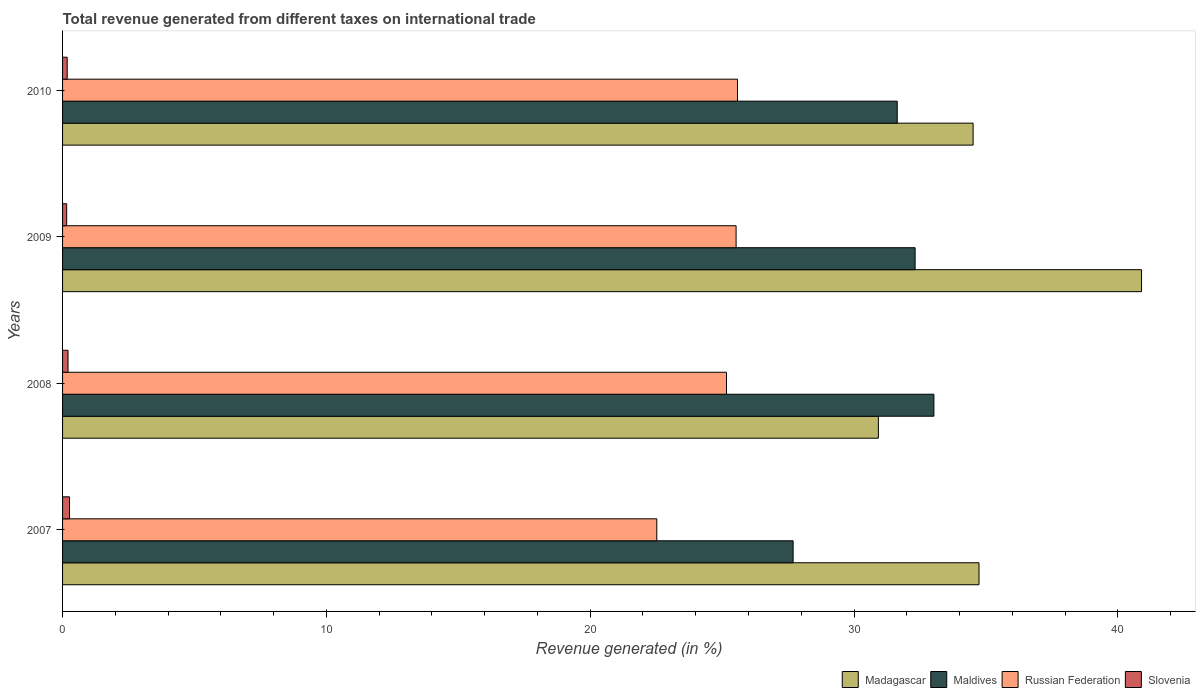Are the number of bars per tick equal to the number of legend labels?
Your answer should be compact. Yes. Are the number of bars on each tick of the Y-axis equal?
Your response must be concise. Yes. How many bars are there on the 3rd tick from the bottom?
Your answer should be very brief. 4. What is the label of the 1st group of bars from the top?
Provide a succinct answer. 2010. In how many cases, is the number of bars for a given year not equal to the number of legend labels?
Offer a very short reply. 0. What is the total revenue generated in Maldives in 2010?
Provide a short and direct response. 31.64. Across all years, what is the maximum total revenue generated in Madagascar?
Keep it short and to the point. 40.9. Across all years, what is the minimum total revenue generated in Russian Federation?
Make the answer very short. 22.52. In which year was the total revenue generated in Slovenia minimum?
Your answer should be very brief. 2009. What is the total total revenue generated in Maldives in the graph?
Offer a very short reply. 124.68. What is the difference between the total revenue generated in Russian Federation in 2007 and that in 2009?
Your response must be concise. -3.01. What is the difference between the total revenue generated in Madagascar in 2010 and the total revenue generated in Maldives in 2008?
Provide a short and direct response. 1.49. What is the average total revenue generated in Russian Federation per year?
Your answer should be very brief. 24.7. In the year 2007, what is the difference between the total revenue generated in Madagascar and total revenue generated in Slovenia?
Provide a short and direct response. 34.47. In how many years, is the total revenue generated in Madagascar greater than 28 %?
Your response must be concise. 4. What is the ratio of the total revenue generated in Russian Federation in 2008 to that in 2010?
Keep it short and to the point. 0.98. Is the total revenue generated in Slovenia in 2007 less than that in 2009?
Ensure brevity in your answer.  No. Is the difference between the total revenue generated in Madagascar in 2009 and 2010 greater than the difference between the total revenue generated in Slovenia in 2009 and 2010?
Offer a very short reply. Yes. What is the difference between the highest and the second highest total revenue generated in Maldives?
Keep it short and to the point. 0.71. What is the difference between the highest and the lowest total revenue generated in Madagascar?
Offer a terse response. 9.98. In how many years, is the total revenue generated in Madagascar greater than the average total revenue generated in Madagascar taken over all years?
Your answer should be compact. 1. Is the sum of the total revenue generated in Madagascar in 2007 and 2009 greater than the maximum total revenue generated in Slovenia across all years?
Offer a terse response. Yes. What does the 4th bar from the top in 2009 represents?
Offer a very short reply. Madagascar. What does the 4th bar from the bottom in 2008 represents?
Your response must be concise. Slovenia. Is it the case that in every year, the sum of the total revenue generated in Slovenia and total revenue generated in Russian Federation is greater than the total revenue generated in Madagascar?
Your answer should be compact. No. How many bars are there?
Provide a succinct answer. 16. Are all the bars in the graph horizontal?
Keep it short and to the point. Yes. How many years are there in the graph?
Ensure brevity in your answer.  4. Are the values on the major ticks of X-axis written in scientific E-notation?
Your response must be concise. No. Does the graph contain any zero values?
Your answer should be compact. No. Does the graph contain grids?
Give a very brief answer. No. Where does the legend appear in the graph?
Keep it short and to the point. Bottom right. How many legend labels are there?
Provide a short and direct response. 4. What is the title of the graph?
Ensure brevity in your answer.  Total revenue generated from different taxes on international trade. What is the label or title of the X-axis?
Your answer should be very brief. Revenue generated (in %). What is the Revenue generated (in %) of Madagascar in 2007?
Offer a terse response. 34.74. What is the Revenue generated (in %) in Maldives in 2007?
Provide a short and direct response. 27.69. What is the Revenue generated (in %) of Russian Federation in 2007?
Offer a terse response. 22.52. What is the Revenue generated (in %) in Slovenia in 2007?
Give a very brief answer. 0.26. What is the Revenue generated (in %) in Madagascar in 2008?
Your answer should be compact. 30.92. What is the Revenue generated (in %) in Maldives in 2008?
Keep it short and to the point. 33.03. What is the Revenue generated (in %) in Russian Federation in 2008?
Offer a terse response. 25.17. What is the Revenue generated (in %) of Slovenia in 2008?
Your answer should be very brief. 0.21. What is the Revenue generated (in %) in Madagascar in 2009?
Keep it short and to the point. 40.9. What is the Revenue generated (in %) of Maldives in 2009?
Ensure brevity in your answer.  32.32. What is the Revenue generated (in %) in Russian Federation in 2009?
Give a very brief answer. 25.53. What is the Revenue generated (in %) of Slovenia in 2009?
Your answer should be very brief. 0.16. What is the Revenue generated (in %) in Madagascar in 2010?
Make the answer very short. 34.52. What is the Revenue generated (in %) of Maldives in 2010?
Your answer should be very brief. 31.64. What is the Revenue generated (in %) in Russian Federation in 2010?
Make the answer very short. 25.58. What is the Revenue generated (in %) of Slovenia in 2010?
Give a very brief answer. 0.18. Across all years, what is the maximum Revenue generated (in %) of Madagascar?
Offer a terse response. 40.9. Across all years, what is the maximum Revenue generated (in %) in Maldives?
Ensure brevity in your answer.  33.03. Across all years, what is the maximum Revenue generated (in %) of Russian Federation?
Offer a very short reply. 25.58. Across all years, what is the maximum Revenue generated (in %) in Slovenia?
Your answer should be compact. 0.26. Across all years, what is the minimum Revenue generated (in %) in Madagascar?
Keep it short and to the point. 30.92. Across all years, what is the minimum Revenue generated (in %) of Maldives?
Your response must be concise. 27.69. Across all years, what is the minimum Revenue generated (in %) of Russian Federation?
Give a very brief answer. 22.52. Across all years, what is the minimum Revenue generated (in %) in Slovenia?
Provide a succinct answer. 0.16. What is the total Revenue generated (in %) of Madagascar in the graph?
Your answer should be compact. 141.08. What is the total Revenue generated (in %) of Maldives in the graph?
Make the answer very short. 124.68. What is the total Revenue generated (in %) in Russian Federation in the graph?
Offer a terse response. 98.8. What is the total Revenue generated (in %) in Slovenia in the graph?
Offer a very short reply. 0.8. What is the difference between the Revenue generated (in %) in Madagascar in 2007 and that in 2008?
Ensure brevity in your answer.  3.82. What is the difference between the Revenue generated (in %) in Maldives in 2007 and that in 2008?
Offer a terse response. -5.34. What is the difference between the Revenue generated (in %) in Russian Federation in 2007 and that in 2008?
Your answer should be very brief. -2.64. What is the difference between the Revenue generated (in %) in Slovenia in 2007 and that in 2008?
Offer a very short reply. 0.06. What is the difference between the Revenue generated (in %) in Madagascar in 2007 and that in 2009?
Provide a short and direct response. -6.16. What is the difference between the Revenue generated (in %) in Maldives in 2007 and that in 2009?
Your answer should be very brief. -4.62. What is the difference between the Revenue generated (in %) of Russian Federation in 2007 and that in 2009?
Your response must be concise. -3.01. What is the difference between the Revenue generated (in %) in Slovenia in 2007 and that in 2009?
Offer a terse response. 0.11. What is the difference between the Revenue generated (in %) in Madagascar in 2007 and that in 2010?
Give a very brief answer. 0.22. What is the difference between the Revenue generated (in %) in Maldives in 2007 and that in 2010?
Offer a very short reply. -3.95. What is the difference between the Revenue generated (in %) in Russian Federation in 2007 and that in 2010?
Your response must be concise. -3.06. What is the difference between the Revenue generated (in %) of Slovenia in 2007 and that in 2010?
Your answer should be very brief. 0.09. What is the difference between the Revenue generated (in %) in Madagascar in 2008 and that in 2009?
Your answer should be compact. -9.98. What is the difference between the Revenue generated (in %) in Maldives in 2008 and that in 2009?
Your answer should be compact. 0.71. What is the difference between the Revenue generated (in %) in Russian Federation in 2008 and that in 2009?
Provide a succinct answer. -0.36. What is the difference between the Revenue generated (in %) of Slovenia in 2008 and that in 2009?
Offer a terse response. 0.05. What is the difference between the Revenue generated (in %) in Madagascar in 2008 and that in 2010?
Provide a succinct answer. -3.59. What is the difference between the Revenue generated (in %) in Maldives in 2008 and that in 2010?
Your response must be concise. 1.39. What is the difference between the Revenue generated (in %) of Russian Federation in 2008 and that in 2010?
Provide a succinct answer. -0.42. What is the difference between the Revenue generated (in %) in Slovenia in 2008 and that in 2010?
Offer a terse response. 0.03. What is the difference between the Revenue generated (in %) in Madagascar in 2009 and that in 2010?
Provide a short and direct response. 6.38. What is the difference between the Revenue generated (in %) of Maldives in 2009 and that in 2010?
Provide a succinct answer. 0.68. What is the difference between the Revenue generated (in %) of Russian Federation in 2009 and that in 2010?
Your response must be concise. -0.05. What is the difference between the Revenue generated (in %) of Slovenia in 2009 and that in 2010?
Offer a terse response. -0.02. What is the difference between the Revenue generated (in %) of Madagascar in 2007 and the Revenue generated (in %) of Maldives in 2008?
Provide a succinct answer. 1.71. What is the difference between the Revenue generated (in %) of Madagascar in 2007 and the Revenue generated (in %) of Russian Federation in 2008?
Offer a terse response. 9.57. What is the difference between the Revenue generated (in %) of Madagascar in 2007 and the Revenue generated (in %) of Slovenia in 2008?
Offer a terse response. 34.53. What is the difference between the Revenue generated (in %) in Maldives in 2007 and the Revenue generated (in %) in Russian Federation in 2008?
Provide a succinct answer. 2.53. What is the difference between the Revenue generated (in %) of Maldives in 2007 and the Revenue generated (in %) of Slovenia in 2008?
Ensure brevity in your answer.  27.48. What is the difference between the Revenue generated (in %) in Russian Federation in 2007 and the Revenue generated (in %) in Slovenia in 2008?
Your answer should be very brief. 22.32. What is the difference between the Revenue generated (in %) of Madagascar in 2007 and the Revenue generated (in %) of Maldives in 2009?
Offer a terse response. 2.42. What is the difference between the Revenue generated (in %) of Madagascar in 2007 and the Revenue generated (in %) of Russian Federation in 2009?
Give a very brief answer. 9.21. What is the difference between the Revenue generated (in %) in Madagascar in 2007 and the Revenue generated (in %) in Slovenia in 2009?
Ensure brevity in your answer.  34.58. What is the difference between the Revenue generated (in %) in Maldives in 2007 and the Revenue generated (in %) in Russian Federation in 2009?
Your answer should be compact. 2.16. What is the difference between the Revenue generated (in %) of Maldives in 2007 and the Revenue generated (in %) of Slovenia in 2009?
Provide a succinct answer. 27.54. What is the difference between the Revenue generated (in %) of Russian Federation in 2007 and the Revenue generated (in %) of Slovenia in 2009?
Your answer should be very brief. 22.37. What is the difference between the Revenue generated (in %) of Madagascar in 2007 and the Revenue generated (in %) of Maldives in 2010?
Your answer should be compact. 3.1. What is the difference between the Revenue generated (in %) in Madagascar in 2007 and the Revenue generated (in %) in Russian Federation in 2010?
Give a very brief answer. 9.16. What is the difference between the Revenue generated (in %) in Madagascar in 2007 and the Revenue generated (in %) in Slovenia in 2010?
Provide a short and direct response. 34.56. What is the difference between the Revenue generated (in %) of Maldives in 2007 and the Revenue generated (in %) of Russian Federation in 2010?
Your answer should be compact. 2.11. What is the difference between the Revenue generated (in %) in Maldives in 2007 and the Revenue generated (in %) in Slovenia in 2010?
Provide a succinct answer. 27.52. What is the difference between the Revenue generated (in %) of Russian Federation in 2007 and the Revenue generated (in %) of Slovenia in 2010?
Keep it short and to the point. 22.35. What is the difference between the Revenue generated (in %) in Madagascar in 2008 and the Revenue generated (in %) in Maldives in 2009?
Offer a terse response. -1.39. What is the difference between the Revenue generated (in %) in Madagascar in 2008 and the Revenue generated (in %) in Russian Federation in 2009?
Provide a short and direct response. 5.39. What is the difference between the Revenue generated (in %) of Madagascar in 2008 and the Revenue generated (in %) of Slovenia in 2009?
Keep it short and to the point. 30.77. What is the difference between the Revenue generated (in %) in Maldives in 2008 and the Revenue generated (in %) in Russian Federation in 2009?
Offer a very short reply. 7.5. What is the difference between the Revenue generated (in %) of Maldives in 2008 and the Revenue generated (in %) of Slovenia in 2009?
Your answer should be compact. 32.87. What is the difference between the Revenue generated (in %) of Russian Federation in 2008 and the Revenue generated (in %) of Slovenia in 2009?
Provide a short and direct response. 25.01. What is the difference between the Revenue generated (in %) of Madagascar in 2008 and the Revenue generated (in %) of Maldives in 2010?
Ensure brevity in your answer.  -0.72. What is the difference between the Revenue generated (in %) of Madagascar in 2008 and the Revenue generated (in %) of Russian Federation in 2010?
Your answer should be very brief. 5.34. What is the difference between the Revenue generated (in %) of Madagascar in 2008 and the Revenue generated (in %) of Slovenia in 2010?
Keep it short and to the point. 30.75. What is the difference between the Revenue generated (in %) in Maldives in 2008 and the Revenue generated (in %) in Russian Federation in 2010?
Your response must be concise. 7.44. What is the difference between the Revenue generated (in %) in Maldives in 2008 and the Revenue generated (in %) in Slovenia in 2010?
Your response must be concise. 32.85. What is the difference between the Revenue generated (in %) in Russian Federation in 2008 and the Revenue generated (in %) in Slovenia in 2010?
Provide a succinct answer. 24.99. What is the difference between the Revenue generated (in %) in Madagascar in 2009 and the Revenue generated (in %) in Maldives in 2010?
Ensure brevity in your answer.  9.26. What is the difference between the Revenue generated (in %) of Madagascar in 2009 and the Revenue generated (in %) of Russian Federation in 2010?
Give a very brief answer. 15.32. What is the difference between the Revenue generated (in %) in Madagascar in 2009 and the Revenue generated (in %) in Slovenia in 2010?
Give a very brief answer. 40.72. What is the difference between the Revenue generated (in %) in Maldives in 2009 and the Revenue generated (in %) in Russian Federation in 2010?
Your answer should be very brief. 6.73. What is the difference between the Revenue generated (in %) of Maldives in 2009 and the Revenue generated (in %) of Slovenia in 2010?
Provide a short and direct response. 32.14. What is the difference between the Revenue generated (in %) of Russian Federation in 2009 and the Revenue generated (in %) of Slovenia in 2010?
Provide a short and direct response. 25.35. What is the average Revenue generated (in %) of Madagascar per year?
Make the answer very short. 35.27. What is the average Revenue generated (in %) of Maldives per year?
Ensure brevity in your answer.  31.17. What is the average Revenue generated (in %) of Russian Federation per year?
Ensure brevity in your answer.  24.7. What is the average Revenue generated (in %) of Slovenia per year?
Keep it short and to the point. 0.2. In the year 2007, what is the difference between the Revenue generated (in %) of Madagascar and Revenue generated (in %) of Maldives?
Your answer should be very brief. 7.05. In the year 2007, what is the difference between the Revenue generated (in %) of Madagascar and Revenue generated (in %) of Russian Federation?
Offer a terse response. 12.21. In the year 2007, what is the difference between the Revenue generated (in %) in Madagascar and Revenue generated (in %) in Slovenia?
Make the answer very short. 34.47. In the year 2007, what is the difference between the Revenue generated (in %) in Maldives and Revenue generated (in %) in Russian Federation?
Ensure brevity in your answer.  5.17. In the year 2007, what is the difference between the Revenue generated (in %) of Maldives and Revenue generated (in %) of Slovenia?
Keep it short and to the point. 27.43. In the year 2007, what is the difference between the Revenue generated (in %) in Russian Federation and Revenue generated (in %) in Slovenia?
Your response must be concise. 22.26. In the year 2008, what is the difference between the Revenue generated (in %) of Madagascar and Revenue generated (in %) of Maldives?
Provide a short and direct response. -2.1. In the year 2008, what is the difference between the Revenue generated (in %) in Madagascar and Revenue generated (in %) in Russian Federation?
Provide a short and direct response. 5.76. In the year 2008, what is the difference between the Revenue generated (in %) in Madagascar and Revenue generated (in %) in Slovenia?
Your answer should be very brief. 30.72. In the year 2008, what is the difference between the Revenue generated (in %) of Maldives and Revenue generated (in %) of Russian Federation?
Give a very brief answer. 7.86. In the year 2008, what is the difference between the Revenue generated (in %) of Maldives and Revenue generated (in %) of Slovenia?
Keep it short and to the point. 32.82. In the year 2008, what is the difference between the Revenue generated (in %) in Russian Federation and Revenue generated (in %) in Slovenia?
Offer a very short reply. 24.96. In the year 2009, what is the difference between the Revenue generated (in %) of Madagascar and Revenue generated (in %) of Maldives?
Your response must be concise. 8.58. In the year 2009, what is the difference between the Revenue generated (in %) of Madagascar and Revenue generated (in %) of Russian Federation?
Offer a terse response. 15.37. In the year 2009, what is the difference between the Revenue generated (in %) in Madagascar and Revenue generated (in %) in Slovenia?
Ensure brevity in your answer.  40.74. In the year 2009, what is the difference between the Revenue generated (in %) in Maldives and Revenue generated (in %) in Russian Federation?
Provide a short and direct response. 6.79. In the year 2009, what is the difference between the Revenue generated (in %) of Maldives and Revenue generated (in %) of Slovenia?
Ensure brevity in your answer.  32.16. In the year 2009, what is the difference between the Revenue generated (in %) of Russian Federation and Revenue generated (in %) of Slovenia?
Provide a short and direct response. 25.37. In the year 2010, what is the difference between the Revenue generated (in %) in Madagascar and Revenue generated (in %) in Maldives?
Offer a very short reply. 2.88. In the year 2010, what is the difference between the Revenue generated (in %) in Madagascar and Revenue generated (in %) in Russian Federation?
Your answer should be compact. 8.93. In the year 2010, what is the difference between the Revenue generated (in %) of Madagascar and Revenue generated (in %) of Slovenia?
Your answer should be very brief. 34.34. In the year 2010, what is the difference between the Revenue generated (in %) of Maldives and Revenue generated (in %) of Russian Federation?
Provide a short and direct response. 6.06. In the year 2010, what is the difference between the Revenue generated (in %) in Maldives and Revenue generated (in %) in Slovenia?
Give a very brief answer. 31.46. In the year 2010, what is the difference between the Revenue generated (in %) of Russian Federation and Revenue generated (in %) of Slovenia?
Offer a very short reply. 25.41. What is the ratio of the Revenue generated (in %) of Madagascar in 2007 to that in 2008?
Give a very brief answer. 1.12. What is the ratio of the Revenue generated (in %) of Maldives in 2007 to that in 2008?
Offer a very short reply. 0.84. What is the ratio of the Revenue generated (in %) in Russian Federation in 2007 to that in 2008?
Provide a short and direct response. 0.9. What is the ratio of the Revenue generated (in %) of Slovenia in 2007 to that in 2008?
Offer a very short reply. 1.28. What is the ratio of the Revenue generated (in %) of Madagascar in 2007 to that in 2009?
Provide a short and direct response. 0.85. What is the ratio of the Revenue generated (in %) of Maldives in 2007 to that in 2009?
Provide a succinct answer. 0.86. What is the ratio of the Revenue generated (in %) of Russian Federation in 2007 to that in 2009?
Offer a very short reply. 0.88. What is the ratio of the Revenue generated (in %) of Slovenia in 2007 to that in 2009?
Make the answer very short. 1.69. What is the ratio of the Revenue generated (in %) of Madagascar in 2007 to that in 2010?
Your answer should be compact. 1.01. What is the ratio of the Revenue generated (in %) in Maldives in 2007 to that in 2010?
Give a very brief answer. 0.88. What is the ratio of the Revenue generated (in %) in Russian Federation in 2007 to that in 2010?
Your answer should be very brief. 0.88. What is the ratio of the Revenue generated (in %) of Slovenia in 2007 to that in 2010?
Your answer should be very brief. 1.5. What is the ratio of the Revenue generated (in %) of Madagascar in 2008 to that in 2009?
Your answer should be very brief. 0.76. What is the ratio of the Revenue generated (in %) in Maldives in 2008 to that in 2009?
Your answer should be very brief. 1.02. What is the ratio of the Revenue generated (in %) of Russian Federation in 2008 to that in 2009?
Provide a succinct answer. 0.99. What is the ratio of the Revenue generated (in %) in Slovenia in 2008 to that in 2009?
Your answer should be very brief. 1.33. What is the ratio of the Revenue generated (in %) of Madagascar in 2008 to that in 2010?
Make the answer very short. 0.9. What is the ratio of the Revenue generated (in %) in Maldives in 2008 to that in 2010?
Offer a terse response. 1.04. What is the ratio of the Revenue generated (in %) of Russian Federation in 2008 to that in 2010?
Your answer should be compact. 0.98. What is the ratio of the Revenue generated (in %) in Slovenia in 2008 to that in 2010?
Offer a terse response. 1.18. What is the ratio of the Revenue generated (in %) in Madagascar in 2009 to that in 2010?
Your response must be concise. 1.19. What is the ratio of the Revenue generated (in %) of Maldives in 2009 to that in 2010?
Provide a succinct answer. 1.02. What is the ratio of the Revenue generated (in %) of Russian Federation in 2009 to that in 2010?
Offer a terse response. 1. What is the ratio of the Revenue generated (in %) of Slovenia in 2009 to that in 2010?
Give a very brief answer. 0.89. What is the difference between the highest and the second highest Revenue generated (in %) of Madagascar?
Provide a succinct answer. 6.16. What is the difference between the highest and the second highest Revenue generated (in %) of Maldives?
Give a very brief answer. 0.71. What is the difference between the highest and the second highest Revenue generated (in %) in Russian Federation?
Your answer should be very brief. 0.05. What is the difference between the highest and the second highest Revenue generated (in %) in Slovenia?
Your answer should be compact. 0.06. What is the difference between the highest and the lowest Revenue generated (in %) in Madagascar?
Your response must be concise. 9.98. What is the difference between the highest and the lowest Revenue generated (in %) of Maldives?
Ensure brevity in your answer.  5.34. What is the difference between the highest and the lowest Revenue generated (in %) of Russian Federation?
Make the answer very short. 3.06. What is the difference between the highest and the lowest Revenue generated (in %) in Slovenia?
Your answer should be compact. 0.11. 